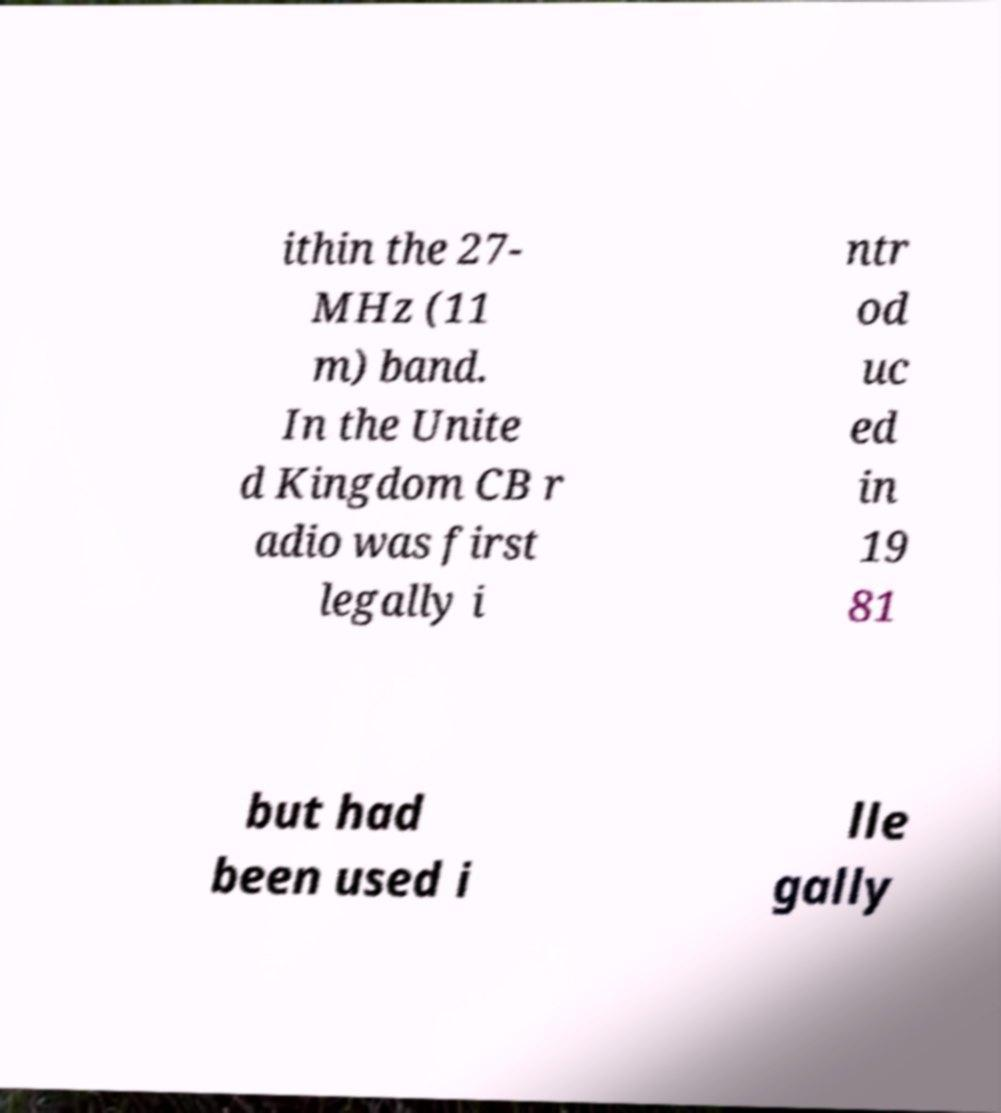Can you read and provide the text displayed in the image?This photo seems to have some interesting text. Can you extract and type it out for me? ithin the 27- MHz (11 m) band. In the Unite d Kingdom CB r adio was first legally i ntr od uc ed in 19 81 but had been used i lle gally 